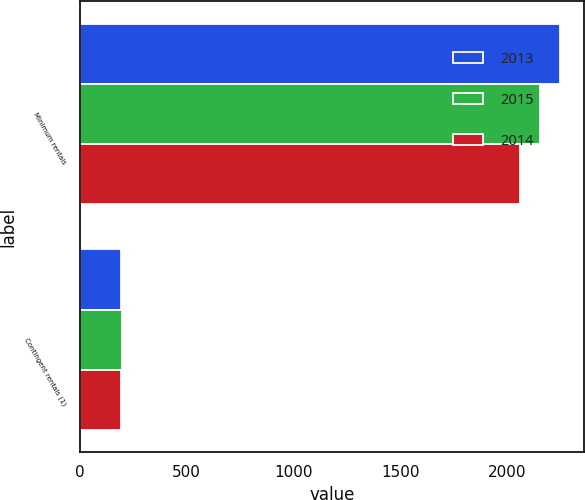Convert chart to OTSL. <chart><loc_0><loc_0><loc_500><loc_500><stacked_bar_chart><ecel><fcel>Minimum rentals<fcel>Contingent rentals (1)<nl><fcel>2013<fcel>2249<fcel>194<nl><fcel>2015<fcel>2154<fcel>197<nl><fcel>2014<fcel>2061<fcel>192<nl></chart> 